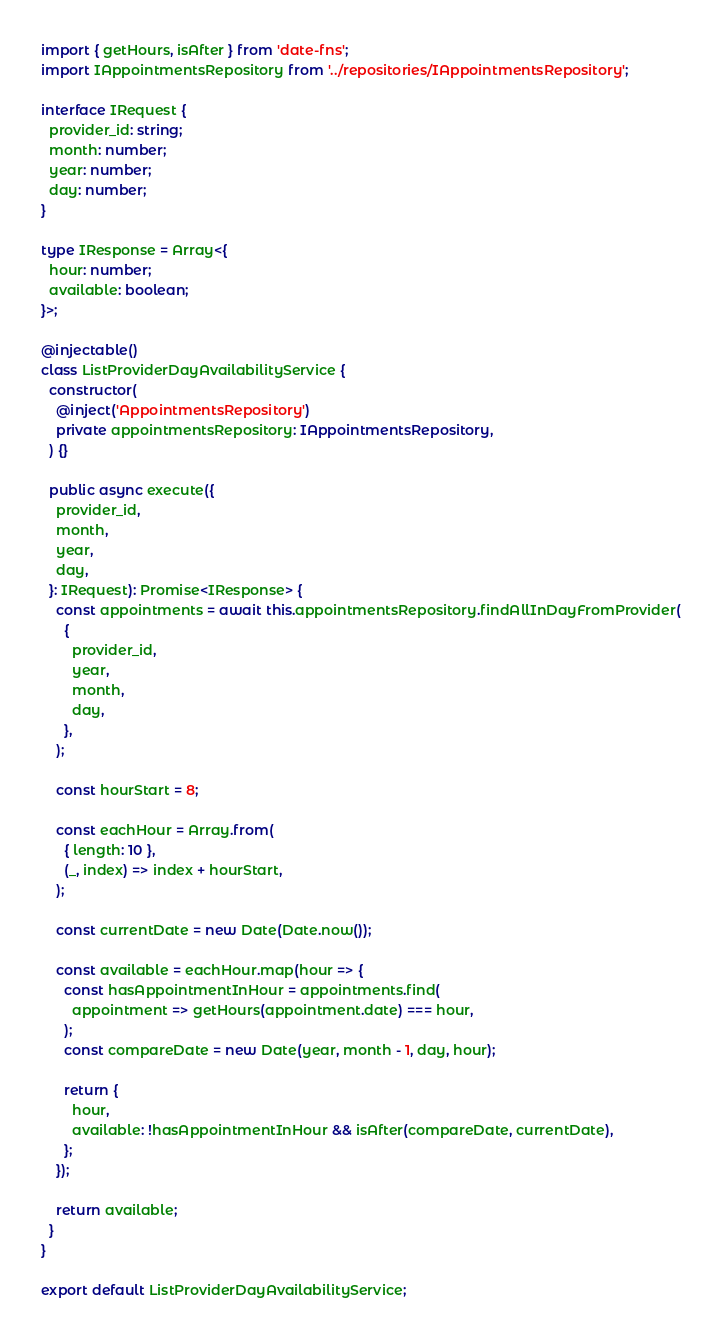Convert code to text. <code><loc_0><loc_0><loc_500><loc_500><_TypeScript_>import { getHours, isAfter } from 'date-fns';
import IAppointmentsRepository from '../repositories/IAppointmentsRepository';

interface IRequest {
  provider_id: string;
  month: number;
  year: number;
  day: number;
}

type IResponse = Array<{
  hour: number;
  available: boolean;
}>;

@injectable()
class ListProviderDayAvailabilityService {
  constructor(
    @inject('AppointmentsRepository')
    private appointmentsRepository: IAppointmentsRepository,
  ) {}

  public async execute({
    provider_id,
    month,
    year,
    day,
  }: IRequest): Promise<IResponse> {
    const appointments = await this.appointmentsRepository.findAllInDayFromProvider(
      {
        provider_id,
        year,
        month,
        day,
      },
    );

    const hourStart = 8;

    const eachHour = Array.from(
      { length: 10 },
      (_, index) => index + hourStart,
    );

    const currentDate = new Date(Date.now());

    const available = eachHour.map(hour => {
      const hasAppointmentInHour = appointments.find(
        appointment => getHours(appointment.date) === hour,
      );
      const compareDate = new Date(year, month - 1, day, hour);

      return {
        hour,
        available: !hasAppointmentInHour && isAfter(compareDate, currentDate),
      };
    });

    return available;
  }
}

export default ListProviderDayAvailabilityService;
</code> 